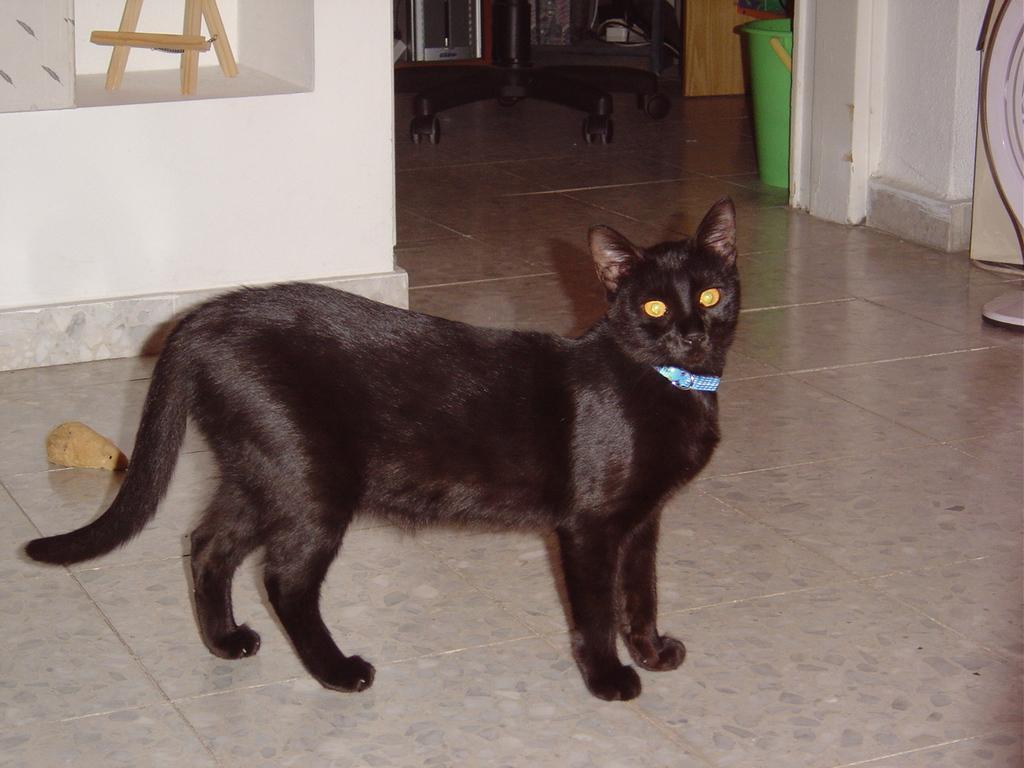How would you summarize this image in a sentence or two? In this image there is a black color cat on the floor. In the background there is a white wall and also a green color object and also table wheels are visible. 